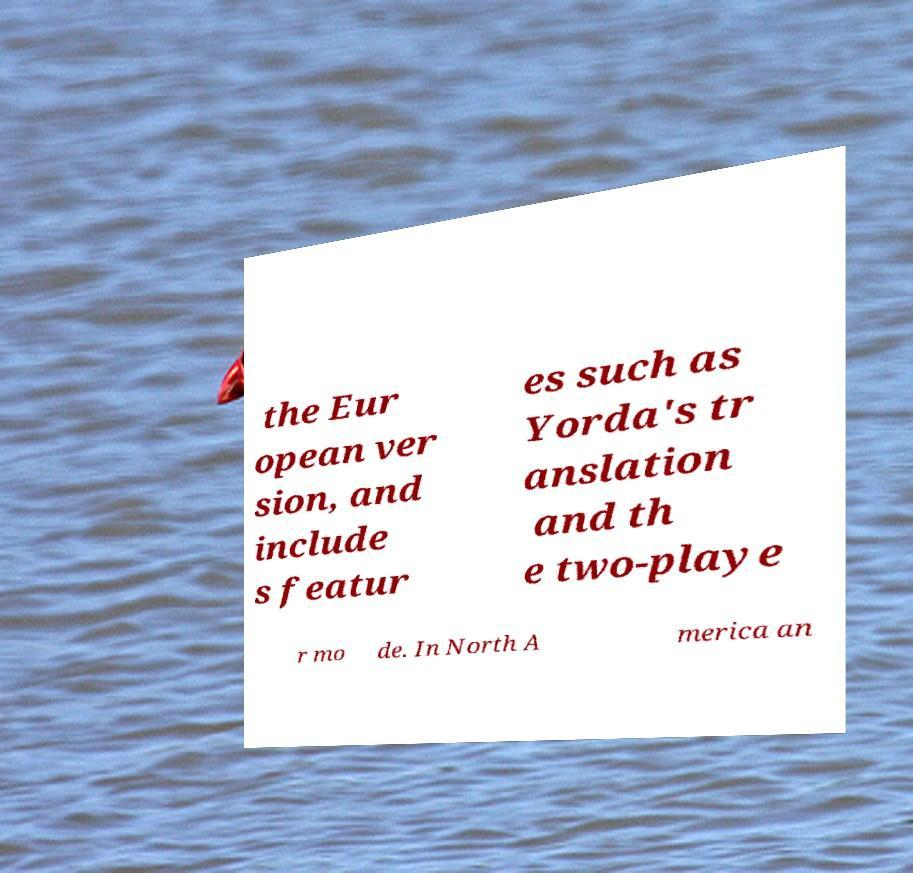Could you extract and type out the text from this image? the Eur opean ver sion, and include s featur es such as Yorda's tr anslation and th e two-playe r mo de. In North A merica an 